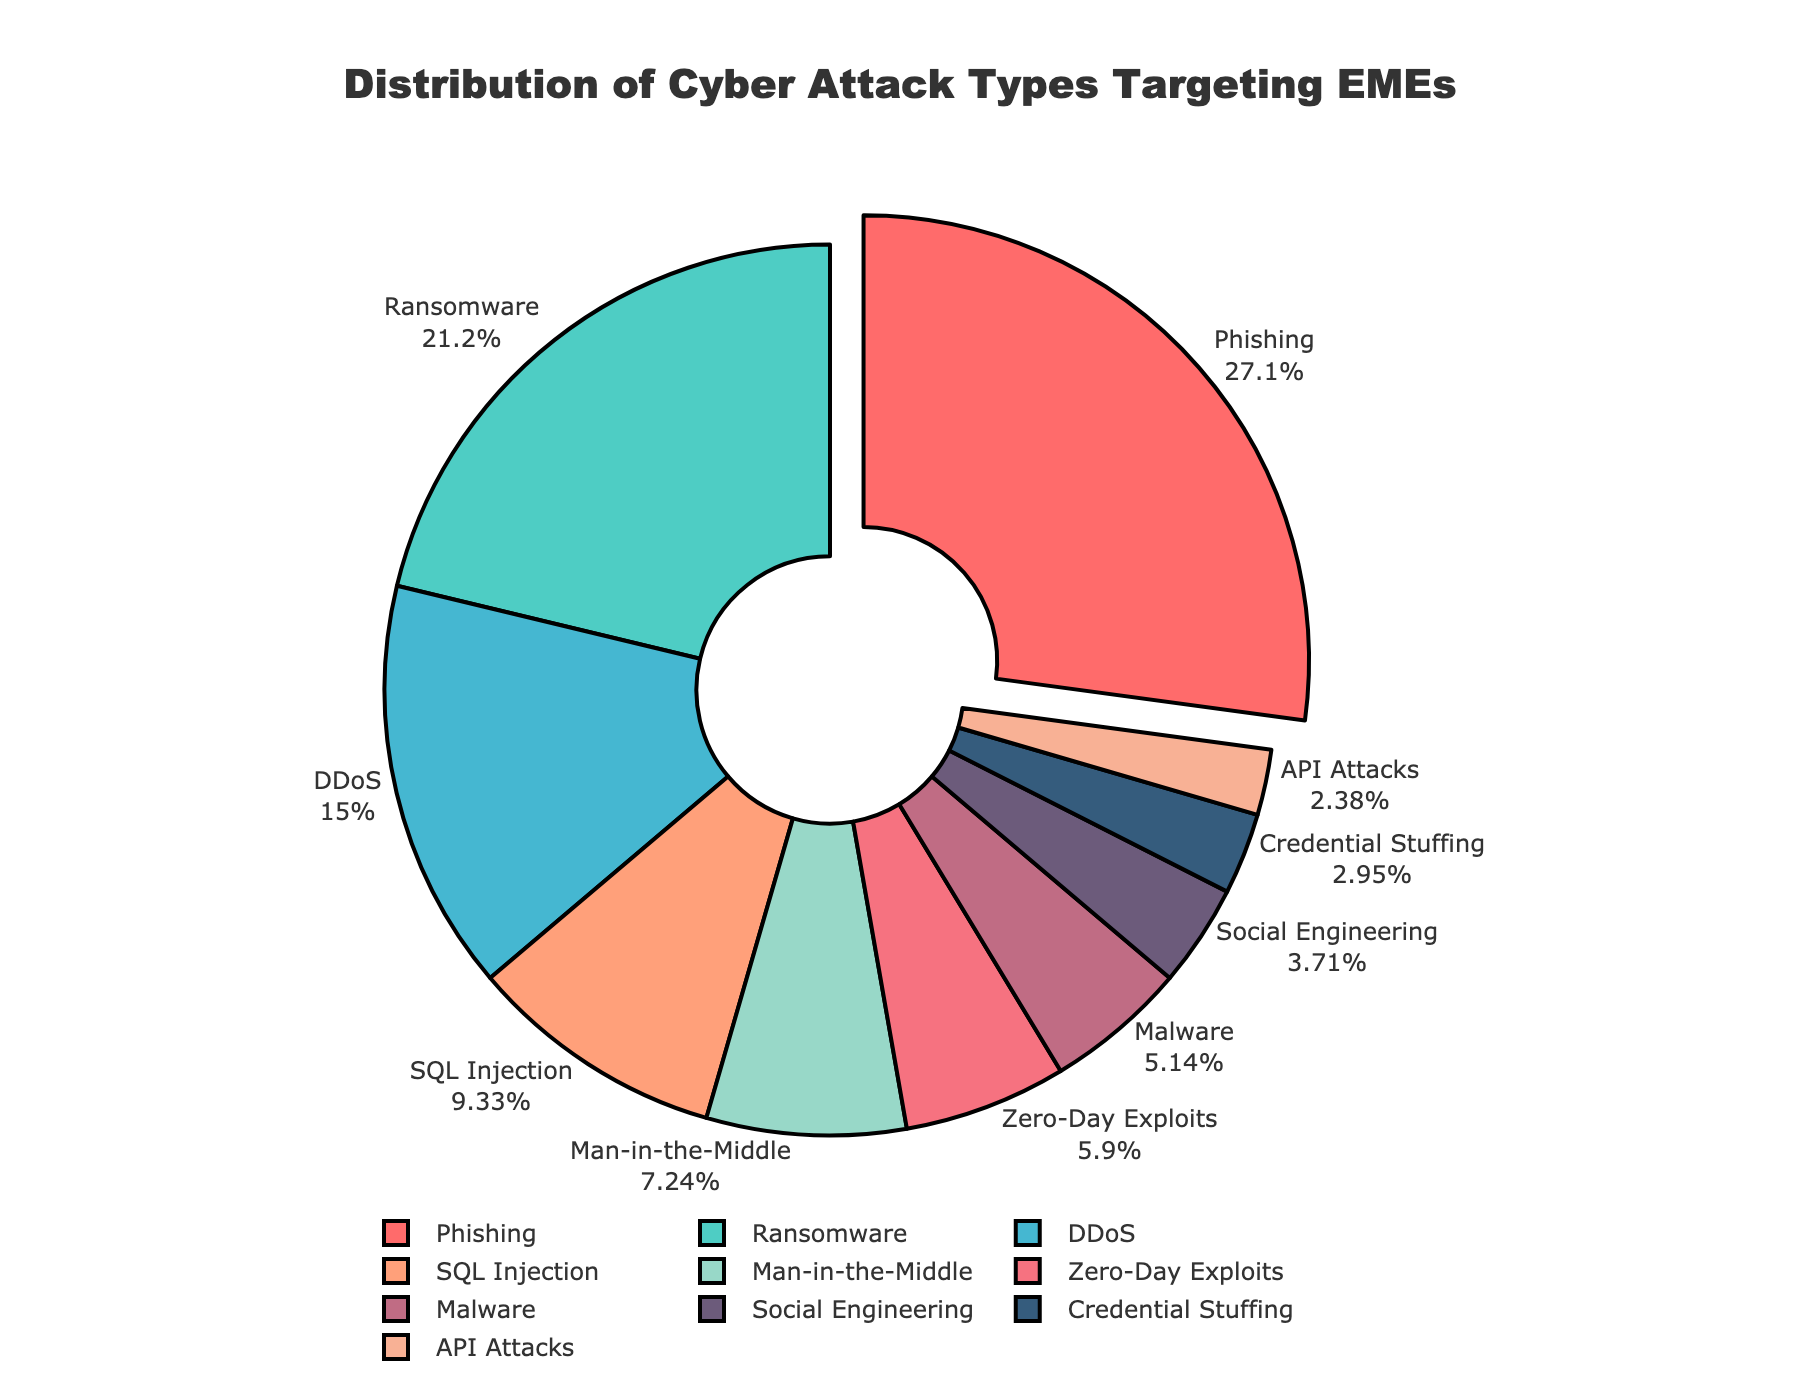Which attack type has the highest percentage? Look at the largest segment of the pie chart or the one that is pulled out slightly. It is labeled "Phishing" with 28.5%.
Answer: Phishing Which attack types together make up more than 50% of the attacks? Add the percentages of the largest segments until you exceed 50%. Phishing (28.5%) + Ransomware (22.3%) = 50.8%.
Answer: Phishing, Ransomware Which attack type has the smallest percentage? Find the smallest segment in the pie chart. It is labeled "API Attacks" with 2.5%.
Answer: API Attacks What's the difference in percentage between Phishing and DDoS attacks? Subtract the percentage of DDoS attacks (15.7%) from the percentage of Phishing attacks (28.5%). 28.5% - 15.7% = 12.8%.
Answer: 12.8% Are Ransomware and Malware combined more common than DDoS attacks? Add the percentages of Ransomware (22.3%) and Malware (5.4%). Then compare this sum to the percentage of DDoS attacks (15.7%). 22.3% + 5.4% = 27.7%, which is greater than 15.7%.
Answer: Yes What is the combined percentage of Man-in-the-Middle and Zero-Day Exploits attacks? Add the percentages of Man-in-the-Middle (7.6%) and Zero-Day Exploits (6.2%). 7.6% + 6.2% = 13.8%.
Answer: 13.8% Which attack types have percentages between 5% and 10%? Identify the segments that fall within the 5% to 10% range. Those are SQL Injection (9.8%), Man-in-the-Middle (7.6%), Zero-Day Exploits (6.2%), and Malware (5.4%).
Answer: SQL Injection, Man-in-the-Middle, Zero-Day Exploits, Malware Of Phishing, Ransomware, and DDoS, which is the least common? Compare the percentages of Phishing (28.5%), Ransomware (22.3%), and DDoS (15.7%). The least common is DDoS with 15.7%.
Answer: DDoS What is the combined percentage of all attacks except the three most common (Phishing, Ransomware, and DDoS)? Subtract the sum of the three most common attacks (Phishing 28.5% + Ransomware 22.3% + DDoS 15.7% = 66.5%) from 100%. 100% - 66.5% = 33.5%.
Answer: 33.5% What fraction of the attacks are Social Engineering and Credential Stuffing combined? Add the percentages of Social Engineering (3.9%) and Credential Stuffing (3.1%), which is 3.9% + 3.1% = 7%. Fraction form is 7/100 or simplified to 7/100.
Answer: 7/100 